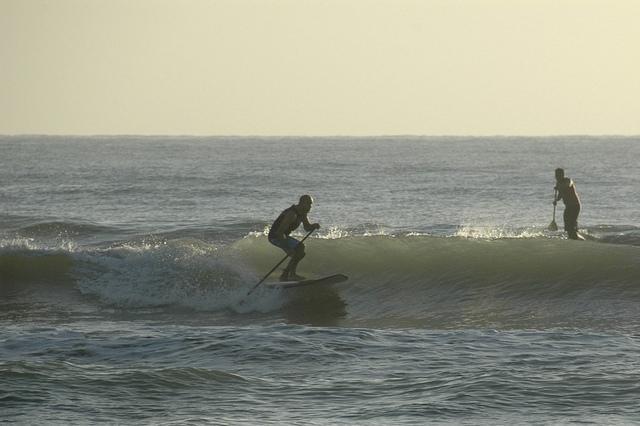What type of equipment are the people holding?
Select the correct answer and articulate reasoning with the following format: 'Answer: answer
Rationale: rationale.'
Options: Oars, water propellers, rowing sticks, surf poles. Answer: oars.
Rationale: Oars are used. 